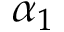<formula> <loc_0><loc_0><loc_500><loc_500>\alpha _ { 1 }</formula> 